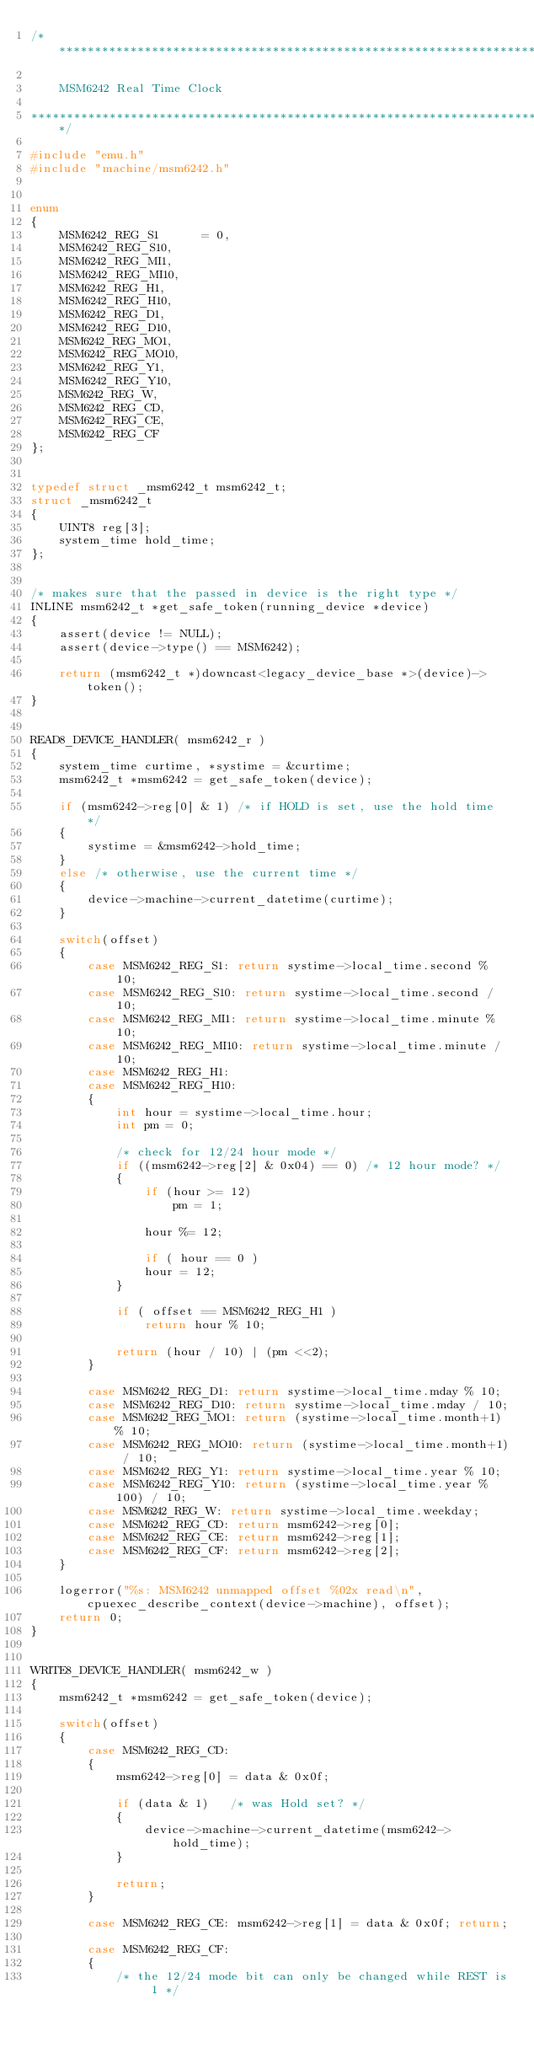<code> <loc_0><loc_0><loc_500><loc_500><_C_>/***************************************************************************

    MSM6242 Real Time Clock

***************************************************************************/

#include "emu.h"
#include "machine/msm6242.h"


enum
{
	MSM6242_REG_S1		= 0,
	MSM6242_REG_S10,
	MSM6242_REG_MI1,
	MSM6242_REG_MI10,
	MSM6242_REG_H1,
	MSM6242_REG_H10,
	MSM6242_REG_D1,
	MSM6242_REG_D10,
	MSM6242_REG_MO1,
	MSM6242_REG_MO10,
	MSM6242_REG_Y1,
	MSM6242_REG_Y10,
	MSM6242_REG_W,
	MSM6242_REG_CD,
	MSM6242_REG_CE,
	MSM6242_REG_CF
};


typedef struct _msm6242_t msm6242_t;
struct _msm6242_t
{
	UINT8 reg[3];
	system_time hold_time;
};


/* makes sure that the passed in device is the right type */
INLINE msm6242_t *get_safe_token(running_device *device)
{
	assert(device != NULL);
	assert(device->type() == MSM6242);

	return (msm6242_t *)downcast<legacy_device_base *>(device)->token();
}


READ8_DEVICE_HANDLER( msm6242_r )
{
	system_time curtime, *systime = &curtime;
	msm6242_t *msm6242 = get_safe_token(device);

	if (msm6242->reg[0] & 1) /* if HOLD is set, use the hold time */
	{
		systime = &msm6242->hold_time;
	}
	else /* otherwise, use the current time */
	{
		device->machine->current_datetime(curtime);
	}

	switch(offset)
	{
		case MSM6242_REG_S1: return systime->local_time.second % 10;
		case MSM6242_REG_S10: return systime->local_time.second / 10;
		case MSM6242_REG_MI1: return systime->local_time.minute % 10;
		case MSM6242_REG_MI10: return systime->local_time.minute / 10;
		case MSM6242_REG_H1:
		case MSM6242_REG_H10:
		{
			int	hour = systime->local_time.hour;
			int pm = 0;

			/* check for 12/24 hour mode */
			if ((msm6242->reg[2] & 0x04) == 0) /* 12 hour mode? */
			{
				if (hour >= 12)
					pm = 1;

				hour %= 12;

				if ( hour == 0 )
				hour = 12;
			}

			if ( offset == MSM6242_REG_H1 )
				return hour % 10;

			return (hour / 10) | (pm <<2);
		}

		case MSM6242_REG_D1: return systime->local_time.mday % 10;
		case MSM6242_REG_D10: return systime->local_time.mday / 10;
		case MSM6242_REG_MO1: return (systime->local_time.month+1) % 10;
		case MSM6242_REG_MO10: return (systime->local_time.month+1) / 10;
		case MSM6242_REG_Y1: return systime->local_time.year % 10;
		case MSM6242_REG_Y10: return (systime->local_time.year % 100) / 10;
		case MSM6242_REG_W: return systime->local_time.weekday;
		case MSM6242_REG_CD: return msm6242->reg[0];
		case MSM6242_REG_CE: return msm6242->reg[1];
		case MSM6242_REG_CF: return msm6242->reg[2];
	}

	logerror("%s: MSM6242 unmapped offset %02x read\n", cpuexec_describe_context(device->machine), offset);
	return 0;
}


WRITE8_DEVICE_HANDLER( msm6242_w )
{
	msm6242_t *msm6242 = get_safe_token(device);

	switch(offset)
	{
		case MSM6242_REG_CD:
		{
			msm6242->reg[0] = data & 0x0f;

			if (data & 1)	/* was Hold set? */
			{
				device->machine->current_datetime(msm6242->hold_time);
			}

			return;
		}

		case MSM6242_REG_CE: msm6242->reg[1] = data & 0x0f; return;

		case MSM6242_REG_CF:
		{
			/* the 12/24 mode bit can only be changed while REST is 1 */</code> 